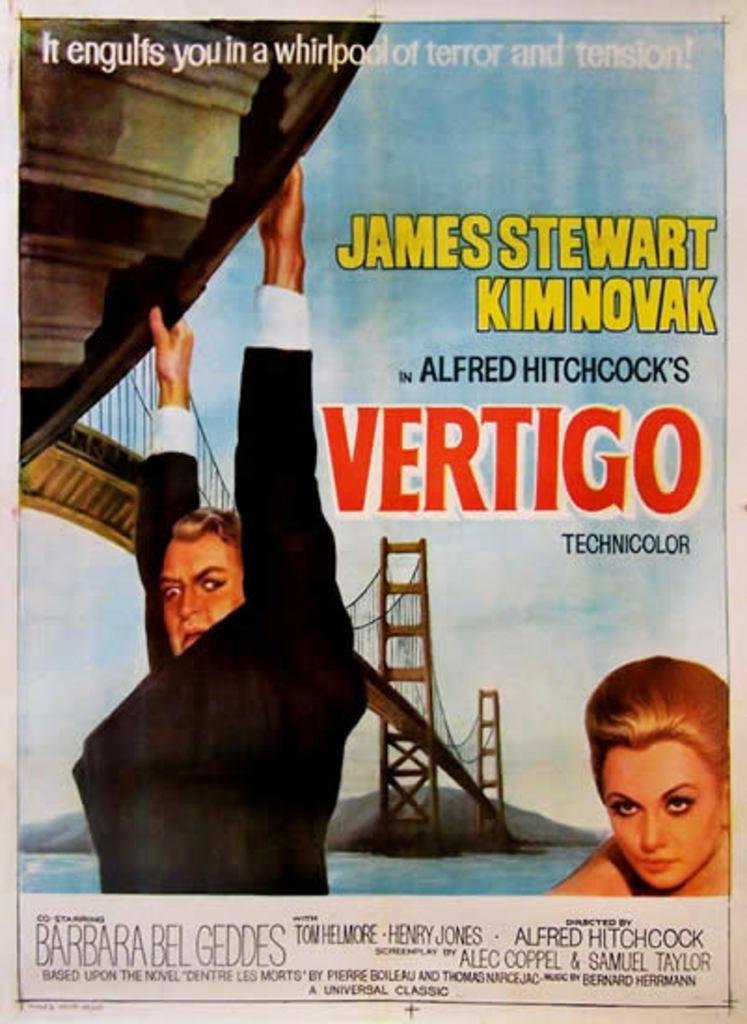<image>
Summarize the visual content of the image. A poster about the movie Vertigo featuring a man and a blonde woman. 